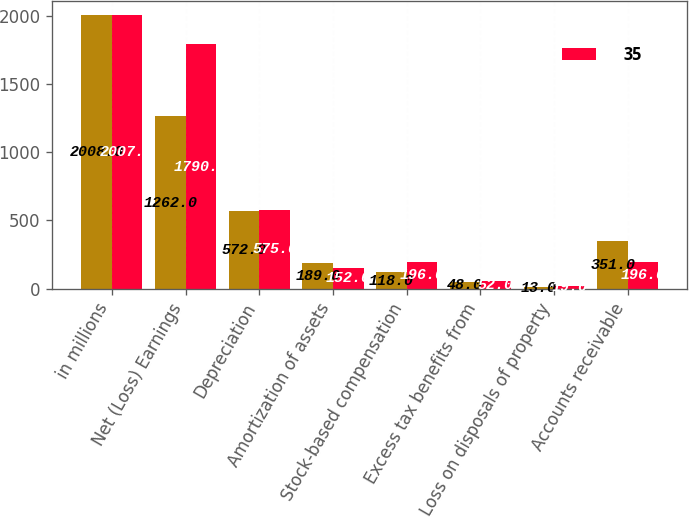Convert chart to OTSL. <chart><loc_0><loc_0><loc_500><loc_500><stacked_bar_chart><ecel><fcel>in millions<fcel>Net (Loss) Earnings<fcel>Depreciation<fcel>Amortization of assets<fcel>Stock-based compensation<fcel>Excess tax benefits from<fcel>Loss on disposals of property<fcel>Accounts receivable<nl><fcel>nan<fcel>2008<fcel>1262<fcel>572<fcel>189<fcel>118<fcel>48<fcel>13<fcel>351<nl><fcel>35<fcel>2007<fcel>1790<fcel>575<fcel>152<fcel>196<fcel>52<fcel>19<fcel>196<nl></chart> 